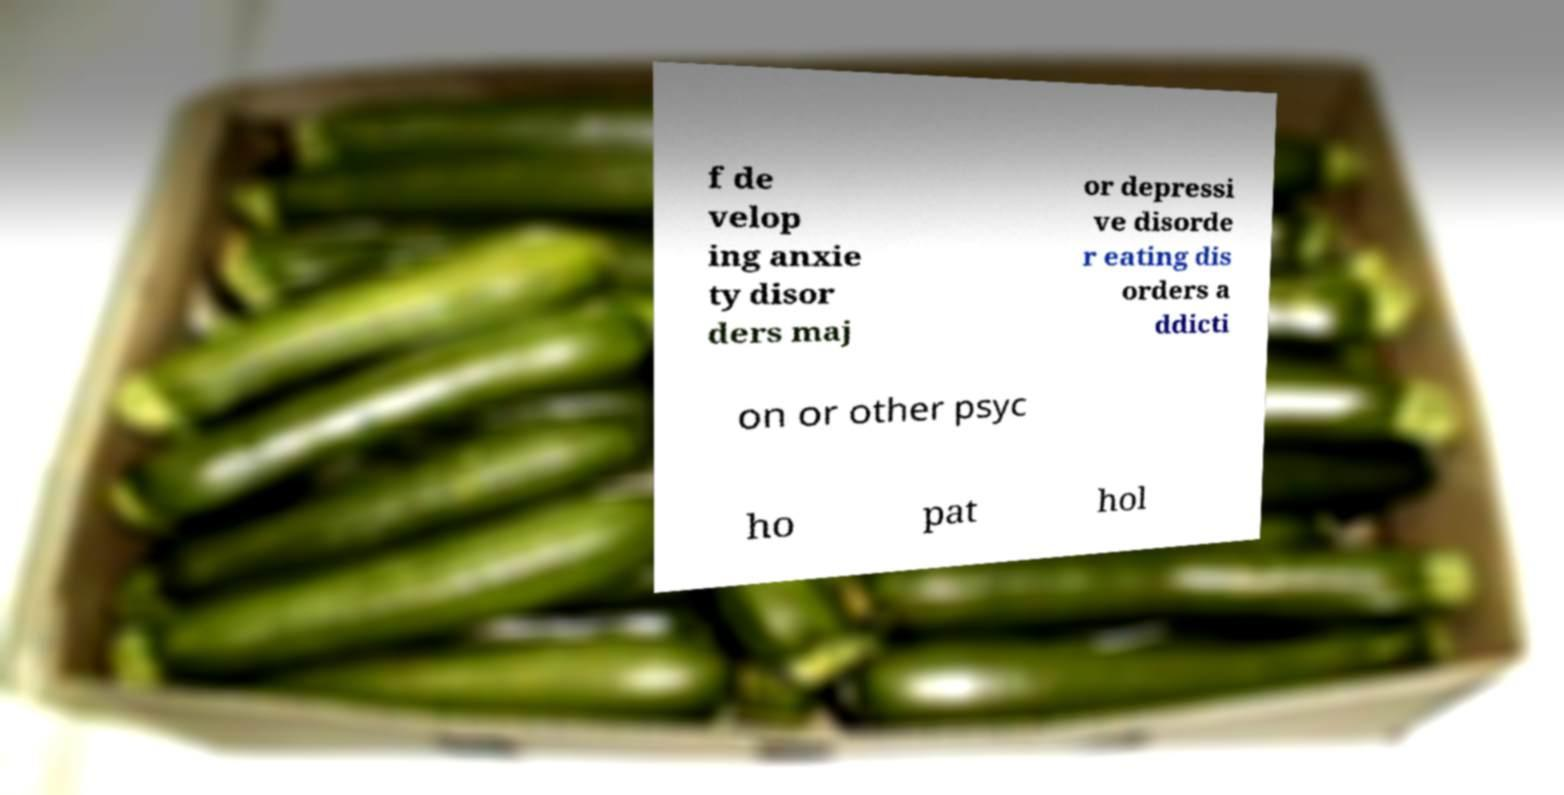For documentation purposes, I need the text within this image transcribed. Could you provide that? f de velop ing anxie ty disor ders maj or depressi ve disorde r eating dis orders a ddicti on or other psyc ho pat hol 